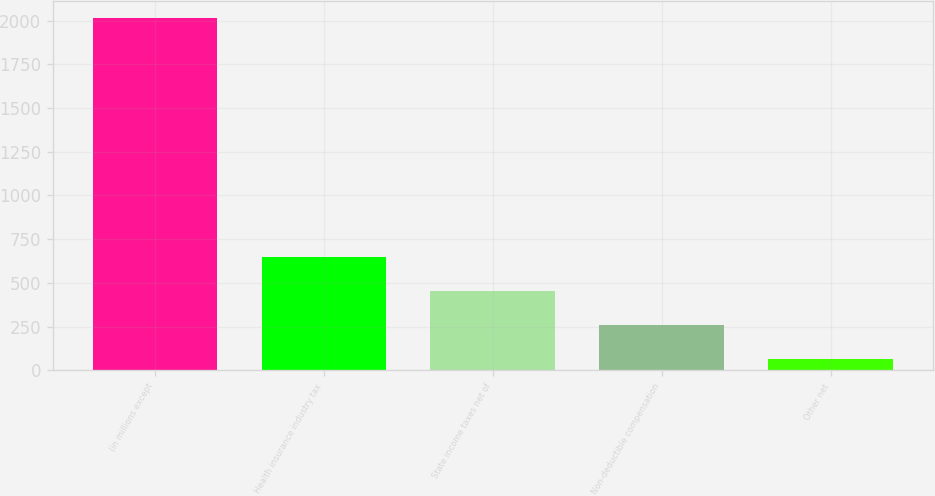Convert chart to OTSL. <chart><loc_0><loc_0><loc_500><loc_500><bar_chart><fcel>(in millions except<fcel>Health insurance industry tax<fcel>State income taxes net of<fcel>Non-deductible compensation<fcel>Other net<nl><fcel>2014<fcel>647.6<fcel>452.4<fcel>257.2<fcel>62<nl></chart> 